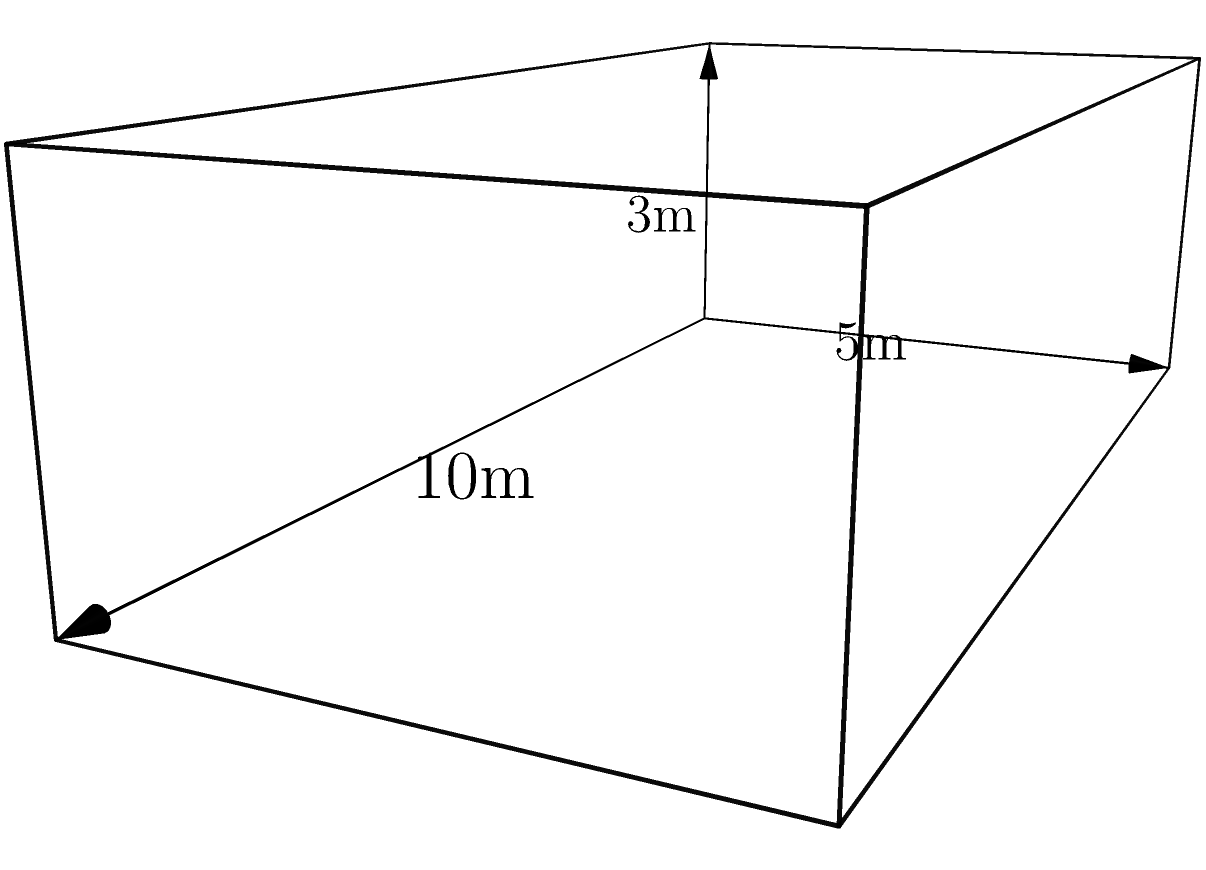A new rectangular prism-shaped barracks building is being constructed as part of a military development project in a small town. The building measures 10 meters in length, 5 meters in width, and 3 meters in height. What is the volume of this barracks building in cubic meters? To calculate the volume of a rectangular prism, we need to multiply its length, width, and height.

Given dimensions:
- Length (l) = 10 meters
- Width (w) = 5 meters
- Height (h) = 3 meters

The formula for the volume of a rectangular prism is:

$$V = l \times w \times h$$

Substituting the values:

$$V = 10 \text{ m} \times 5 \text{ m} \times 3 \text{ m}$$

$$V = 150 \text{ m}^3$$

Therefore, the volume of the barracks building is 150 cubic meters.
Answer: 150 m³ 